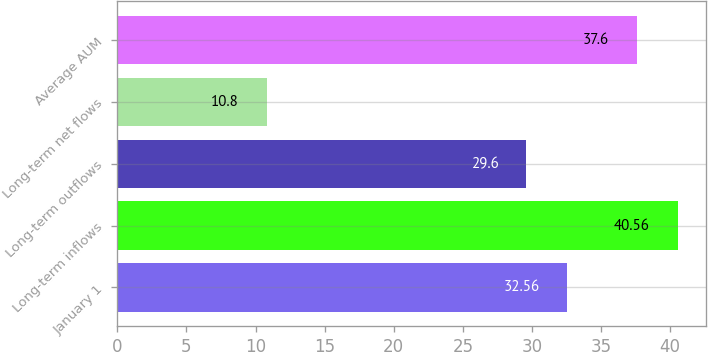Convert chart to OTSL. <chart><loc_0><loc_0><loc_500><loc_500><bar_chart><fcel>January 1<fcel>Long-term inflows<fcel>Long-term outflows<fcel>Long-term net flows<fcel>Average AUM<nl><fcel>32.56<fcel>40.56<fcel>29.6<fcel>10.8<fcel>37.6<nl></chart> 